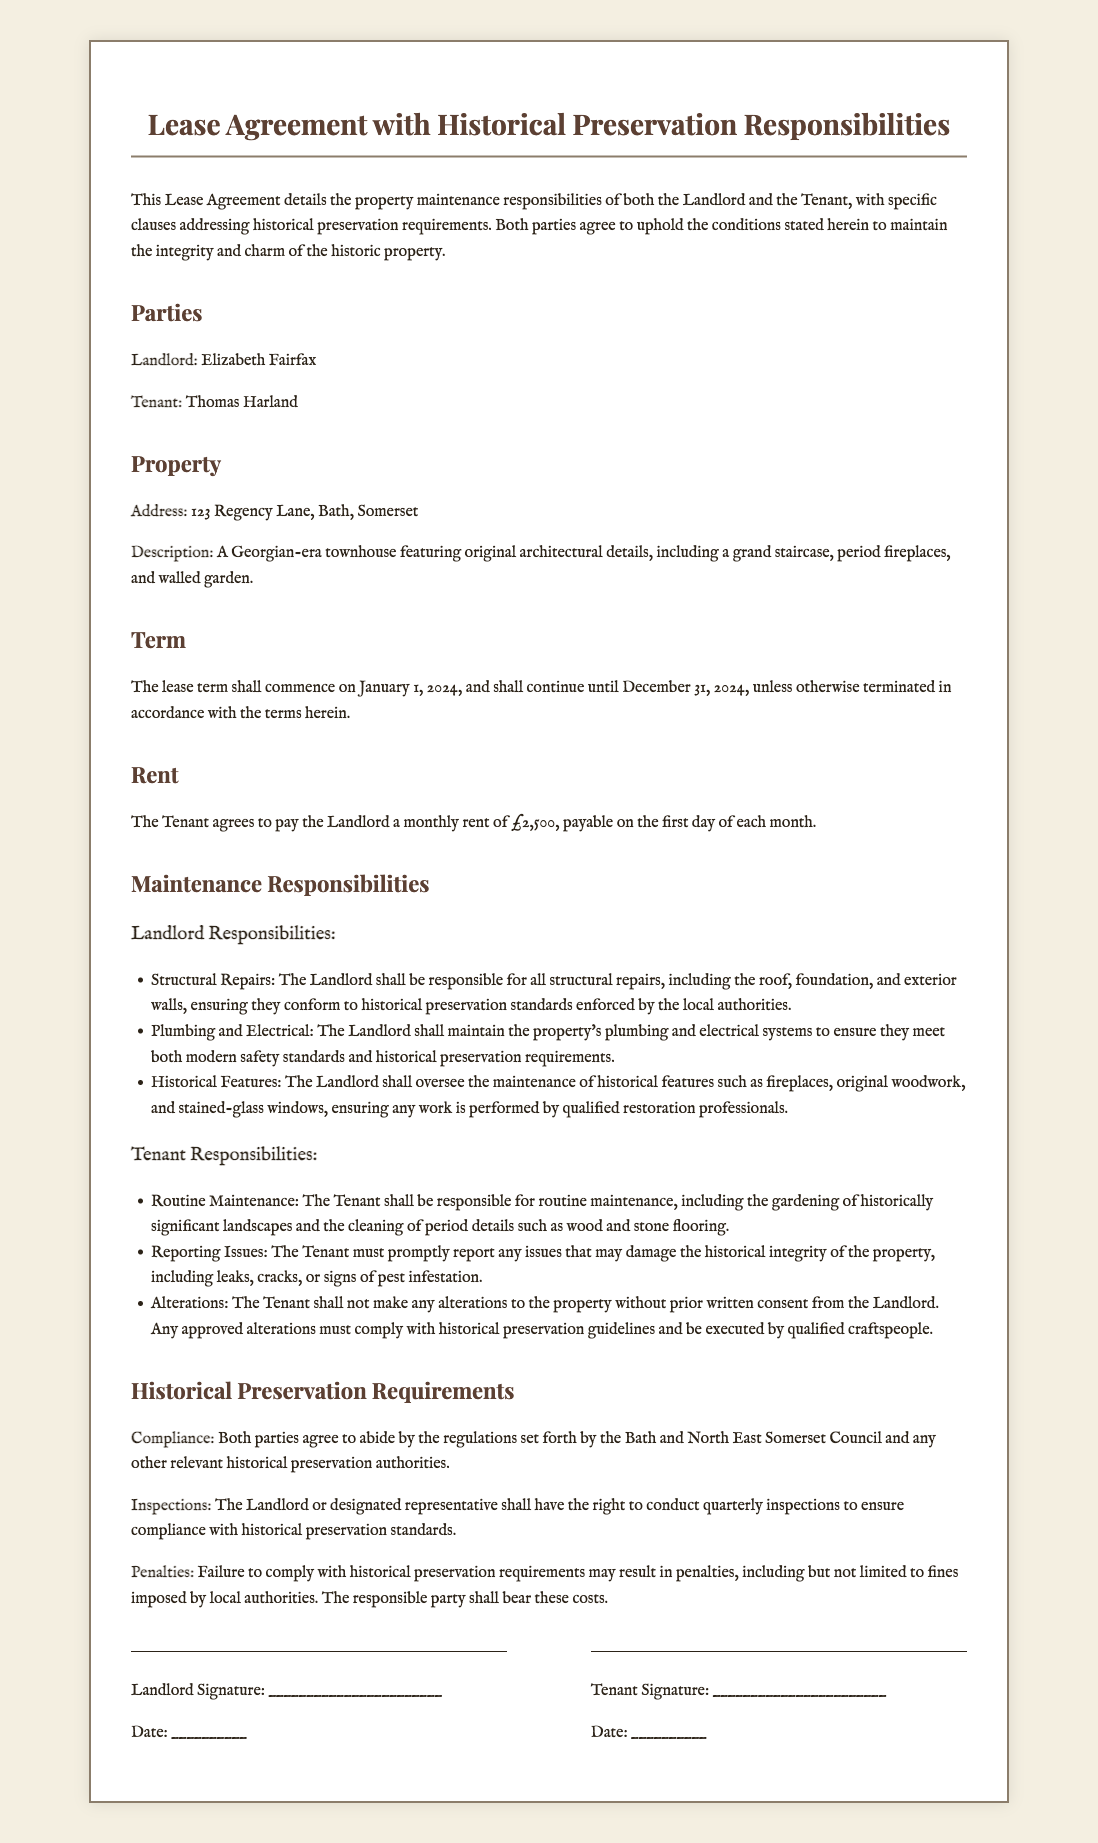What is the name of the landlord? The landlord's name is specified in the document as Elizabeth Fairfax.
Answer: Elizabeth Fairfax What is the monthly rent amount? The monthly rent amount is detailed in the rent section of the document, which states it is £2,500.
Answer: £2,500 What is the tenant's responsibility regarding historical features? The tenant must not make any alterations to the property without prior written consent from the landlord.
Answer: No alterations What compliance regulations must both parties abide by? The document states that both parties must comply with the regulations set forth by the Bath and North East Somerset Council.
Answer: Bath and North East Somerset Council How often may the landlord conduct inspections? The document specifies that the landlord can conduct inspections quarterly to ensure compliance.
Answer: Quarterly What is the term of the lease? The lease term is stated to commence on January 1, 2024, and continue until December 31, 2024.
Answer: January 1, 2024, to December 31, 2024 Which feature is included in the property's description? The property's description mentions a grand staircase among other historical features of the Georgian-era townhouse.
Answer: Grand staircase Who is responsible for plumbing and electrical systems? The document states that the landlord is responsible for maintaining the property's plumbing and electrical systems.
Answer: Landlord What happens if historical preservation requirements are not complied with? The document outlines that failure to comply may result in penalties, including fines imposed by local authorities.
Answer: Fines 